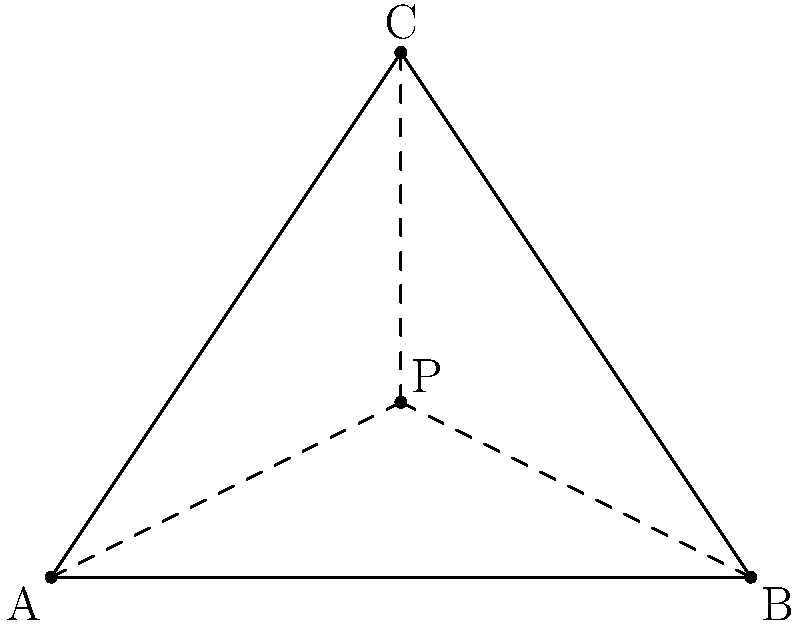In the triangle ABC shown above, point P is located at coordinates (2,1). Using barycentric coordinates, determine the weights (α, β, γ) for point P with respect to vertices A, B, and C. How can these coordinates be utilized in computer graphics and game development applications? To solve this problem, we'll follow these steps:

1. Calculate the area of the entire triangle ABC using the formula:
   $$Area_{ABC} = \frac{1}{2}|x_A(y_B - y_C) + x_B(y_C - y_A) + x_C(y_A - y_B)|$$

2. Calculate the areas of sub-triangles PBC, PCA, and PAB using the same formula.

3. Compute the barycentric coordinates (α, β, γ) using the ratios of these areas:
   $$α = \frac{Area_{PBC}}{Area_{ABC}}, β = \frac{Area_{PCA}}{Area_{ABC}}, γ = \frac{Area_{PAB}}{Area_{ABC}}$$

Step 1: Calculate Area_{ABC}
$$Area_{ABC} = \frac{1}{2}|0(0-3) + 4(3-0) + 2(0-0)| = 6$$

Step 2: Calculate sub-triangle areas
$$Area_{PBC} = \frac{1}{2}|2(0-3) + 4(3-1) + 2(1-0)| = 2$$
$$Area_{PCA} = \frac{1}{2}|0(1-3) + 2(3-0) + 2(0-1)| = 2$$
$$Area_{PAB} = \frac{1}{2}|0(1-0) + 4(0-1) + 2(0-0)| = 2$$

Step 3: Compute barycentric coordinates
$$α = \frac{Area_{PBC}}{Area_{ABC}} = \frac{2}{6} = \frac{1}{3}$$
$$β = \frac{Area_{PCA}}{Area_{ABC}} = \frac{2}{6} = \frac{1}{3}$$
$$γ = \frac{Area_{PAB}}{Area_{ABC}} = \frac{2}{6} = \frac{1}{3}$$

Applications in computer graphics and game development:

1. Texture mapping: Barycentric coordinates can be used to interpolate texture coordinates across a triangle, enabling smooth texture mapping.

2. Collision detection: They help determine if a point lies inside or outside a triangle, which is crucial for collision detection algorithms.

3. Mesh deformation: Barycentric coordinates can be used to smoothly deform 3D meshes by interpolating vertex positions.

4. Shading and lighting: They allow for smooth interpolation of vertex attributes like normals and colors across a triangle's surface.

5. Particle systems: Barycentric coordinates can be used to constrain particles within triangular regions or distribute them across surfaces.
Answer: Barycentric coordinates: (α, β, γ) = (1/3, 1/3, 1/3). Applications: texture mapping, collision detection, mesh deformation, shading, and particle systems. 